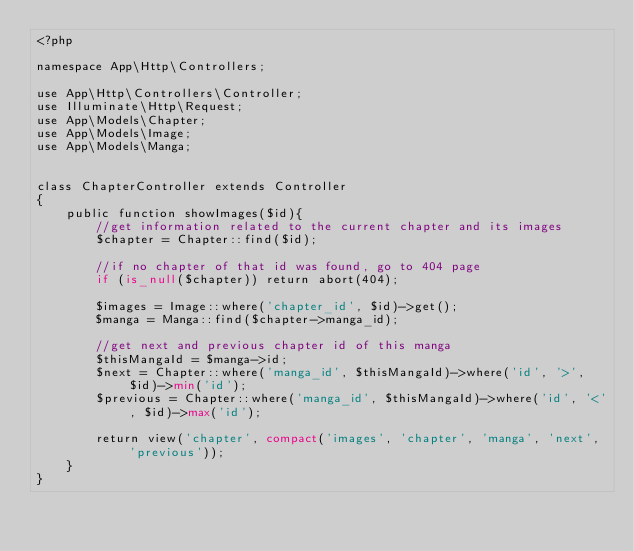<code> <loc_0><loc_0><loc_500><loc_500><_PHP_><?php

namespace App\Http\Controllers;

use App\Http\Controllers\Controller;
use Illuminate\Http\Request;
use App\Models\Chapter;
use App\Models\Image;
use App\Models\Manga;


class ChapterController extends Controller
{
    public function showImages($id){
        //get information related to the current chapter and its images
        $chapter = Chapter::find($id);

        //if no chapter of that id was found, go to 404 page
        if (is_null($chapter)) return abort(404);

        $images = Image::where('chapter_id', $id)->get();
        $manga = Manga::find($chapter->manga_id);

        //get next and previous chapter id of this manga
        $thisMangaId = $manga->id;
        $next = Chapter::where('manga_id', $thisMangaId)->where('id', '>', $id)->min('id');
        $previous = Chapter::where('manga_id', $thisMangaId)->where('id', '<', $id)->max('id');

        return view('chapter', compact('images', 'chapter', 'manga', 'next', 'previous'));
    }
}
</code> 